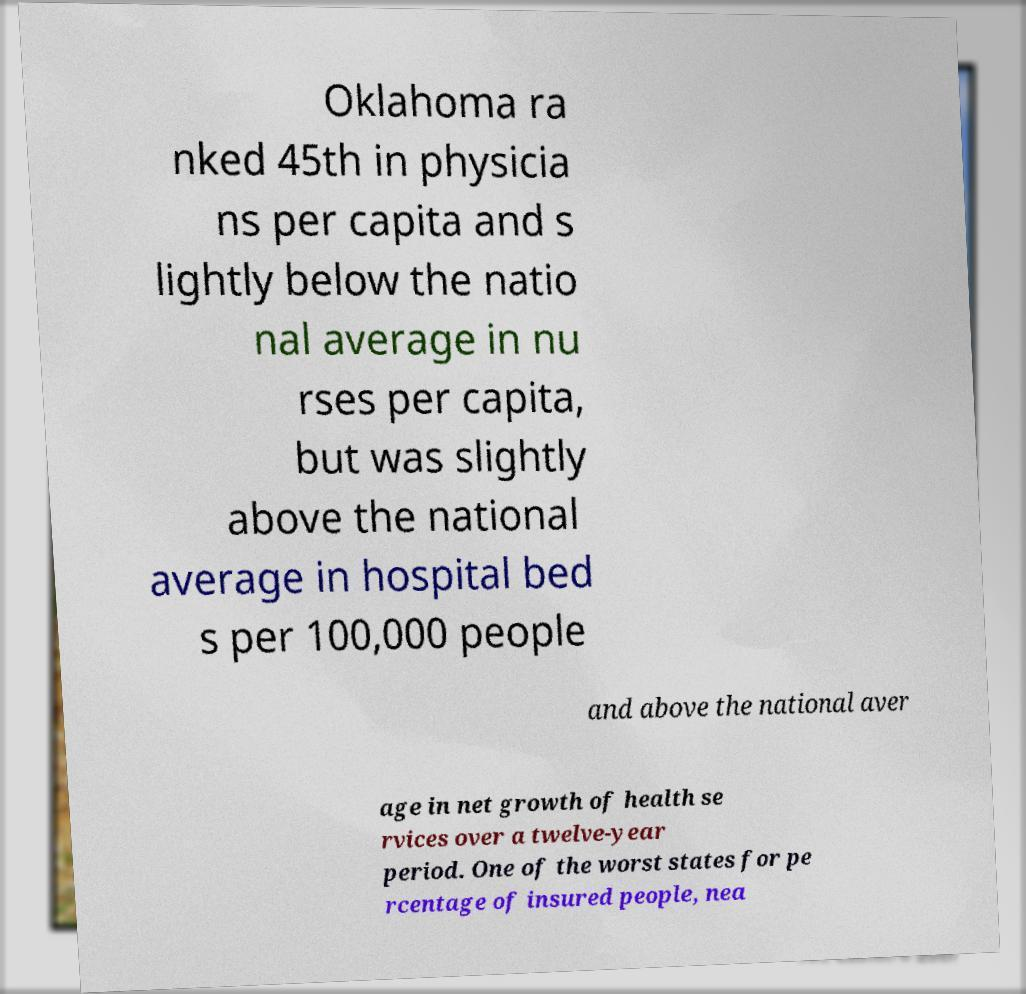Can you accurately transcribe the text from the provided image for me? Oklahoma ra nked 45th in physicia ns per capita and s lightly below the natio nal average in nu rses per capita, but was slightly above the national average in hospital bed s per 100,000 people and above the national aver age in net growth of health se rvices over a twelve-year period. One of the worst states for pe rcentage of insured people, nea 